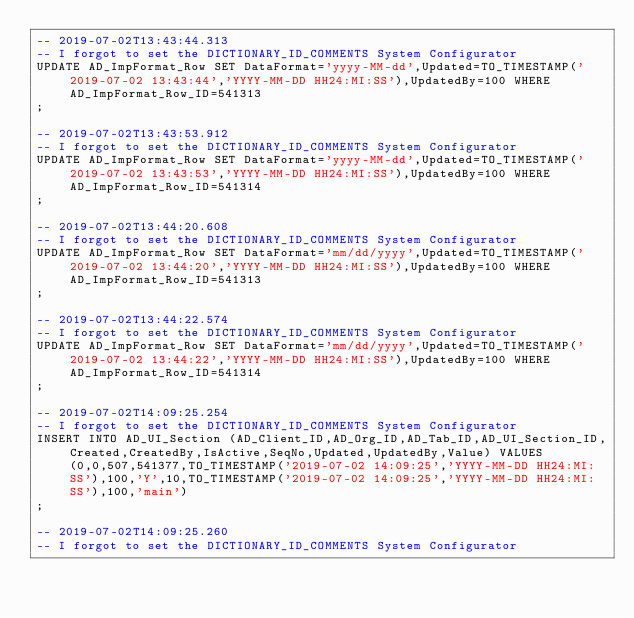<code> <loc_0><loc_0><loc_500><loc_500><_SQL_>-- 2019-07-02T13:43:44.313
-- I forgot to set the DICTIONARY_ID_COMMENTS System Configurator
UPDATE AD_ImpFormat_Row SET DataFormat='yyyy-MM-dd',Updated=TO_TIMESTAMP('2019-07-02 13:43:44','YYYY-MM-DD HH24:MI:SS'),UpdatedBy=100 WHERE AD_ImpFormat_Row_ID=541313
;

-- 2019-07-02T13:43:53.912
-- I forgot to set the DICTIONARY_ID_COMMENTS System Configurator
UPDATE AD_ImpFormat_Row SET DataFormat='yyyy-MM-dd',Updated=TO_TIMESTAMP('2019-07-02 13:43:53','YYYY-MM-DD HH24:MI:SS'),UpdatedBy=100 WHERE AD_ImpFormat_Row_ID=541314
;

-- 2019-07-02T13:44:20.608
-- I forgot to set the DICTIONARY_ID_COMMENTS System Configurator
UPDATE AD_ImpFormat_Row SET DataFormat='mm/dd/yyyy',Updated=TO_TIMESTAMP('2019-07-02 13:44:20','YYYY-MM-DD HH24:MI:SS'),UpdatedBy=100 WHERE AD_ImpFormat_Row_ID=541313
;

-- 2019-07-02T13:44:22.574
-- I forgot to set the DICTIONARY_ID_COMMENTS System Configurator
UPDATE AD_ImpFormat_Row SET DataFormat='mm/dd/yyyy',Updated=TO_TIMESTAMP('2019-07-02 13:44:22','YYYY-MM-DD HH24:MI:SS'),UpdatedBy=100 WHERE AD_ImpFormat_Row_ID=541314
;

-- 2019-07-02T14:09:25.254
-- I forgot to set the DICTIONARY_ID_COMMENTS System Configurator
INSERT INTO AD_UI_Section (AD_Client_ID,AD_Org_ID,AD_Tab_ID,AD_UI_Section_ID,Created,CreatedBy,IsActive,SeqNo,Updated,UpdatedBy,Value) VALUES (0,0,507,541377,TO_TIMESTAMP('2019-07-02 14:09:25','YYYY-MM-DD HH24:MI:SS'),100,'Y',10,TO_TIMESTAMP('2019-07-02 14:09:25','YYYY-MM-DD HH24:MI:SS'),100,'main')
;

-- 2019-07-02T14:09:25.260
-- I forgot to set the DICTIONARY_ID_COMMENTS System Configurator</code> 